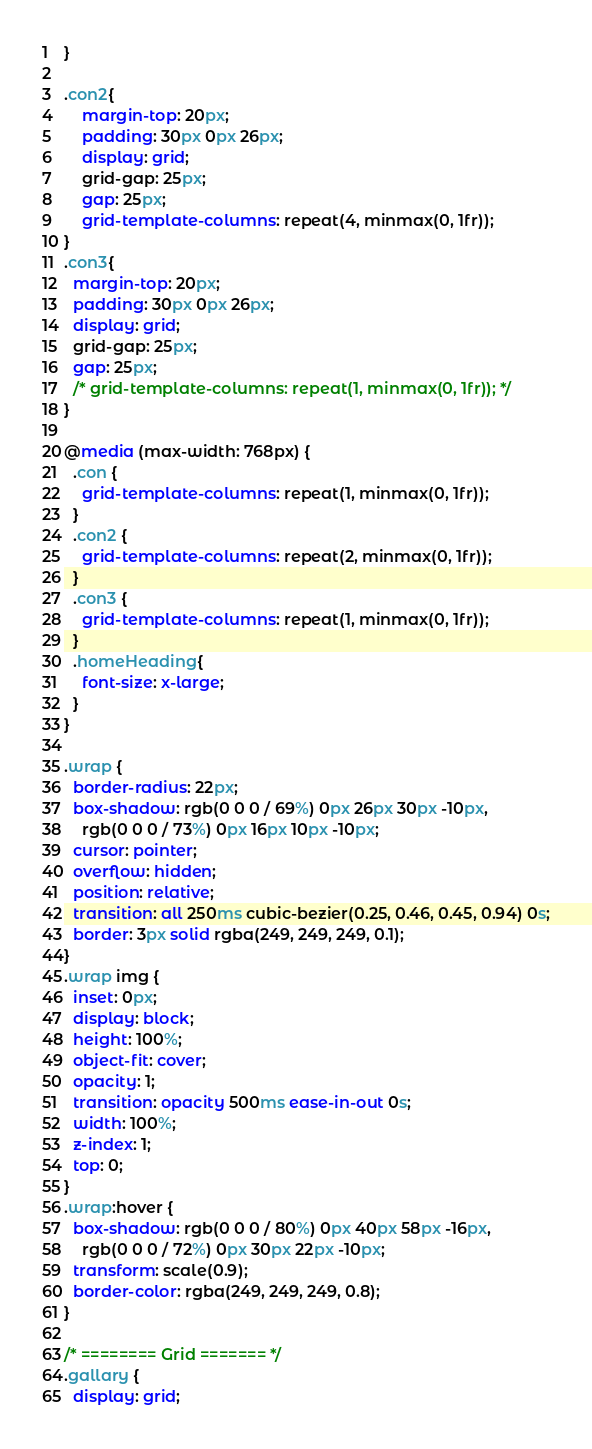Convert code to text. <code><loc_0><loc_0><loc_500><loc_500><_CSS_>}

.con2{
    margin-top: 20px;
    padding: 30px 0px 26px;
    display: grid;
    grid-gap: 25px;
    gap: 25px;
    grid-template-columns: repeat(4, minmax(0, 1fr));
}
.con3{
  margin-top: 20px;
  padding: 30px 0px 26px;
  display: grid;
  grid-gap: 25px;
  gap: 25px;
  /* grid-template-columns: repeat(1, minmax(0, 1fr)); */
}

@media (max-width: 768px) {
  .con {
    grid-template-columns: repeat(1, minmax(0, 1fr));
  }
  .con2 {
    grid-template-columns: repeat(2, minmax(0, 1fr));
  }
  .con3 {
    grid-template-columns: repeat(1, minmax(0, 1fr));
  }
  .homeHeading{
    font-size: x-large;
  } 
}

.wrap {
  border-radius: 22px;
  box-shadow: rgb(0 0 0 / 69%) 0px 26px 30px -10px,
    rgb(0 0 0 / 73%) 0px 16px 10px -10px;
  cursor: pointer;
  overflow: hidden;
  position: relative;
  transition: all 250ms cubic-bezier(0.25, 0.46, 0.45, 0.94) 0s;
  border: 3px solid rgba(249, 249, 249, 0.1);
}
.wrap img {
  inset: 0px;
  display: block;
  height: 100%;
  object-fit: cover;
  opacity: 1;
  transition: opacity 500ms ease-in-out 0s;
  width: 100%;
  z-index: 1;
  top: 0;
}
.wrap:hover {
  box-shadow: rgb(0 0 0 / 80%) 0px 40px 58px -16px,
    rgb(0 0 0 / 72%) 0px 30px 22px -10px;
  transform: scale(0.9);
  border-color: rgba(249, 249, 249, 0.8);
}

/* ======== Grid ======= */
.gallary {
  display: grid;</code> 